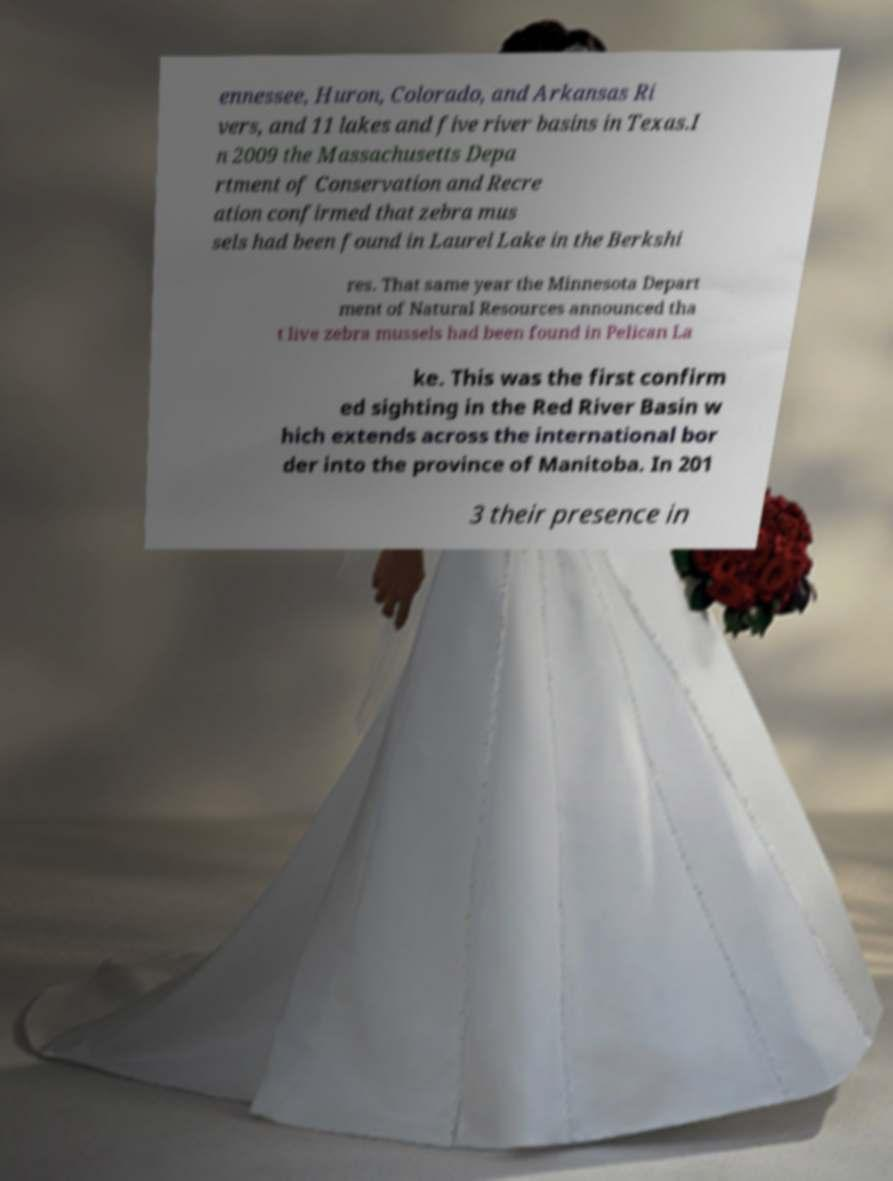Please identify and transcribe the text found in this image. ennessee, Huron, Colorado, and Arkansas Ri vers, and 11 lakes and five river basins in Texas.I n 2009 the Massachusetts Depa rtment of Conservation and Recre ation confirmed that zebra mus sels had been found in Laurel Lake in the Berkshi res. That same year the Minnesota Depart ment of Natural Resources announced tha t live zebra mussels had been found in Pelican La ke. This was the first confirm ed sighting in the Red River Basin w hich extends across the international bor der into the province of Manitoba. In 201 3 their presence in 